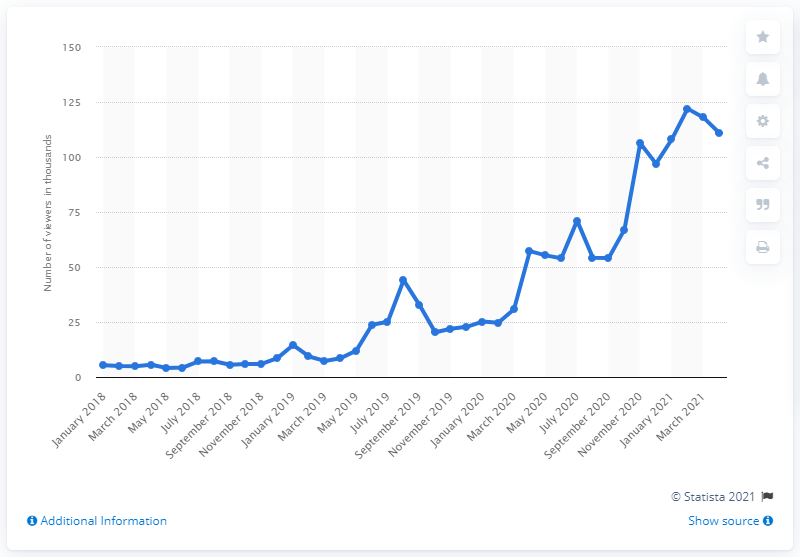Mention a couple of crucial points in this snapshot. Twitch began showcasing Minecraft events in April 2021. 